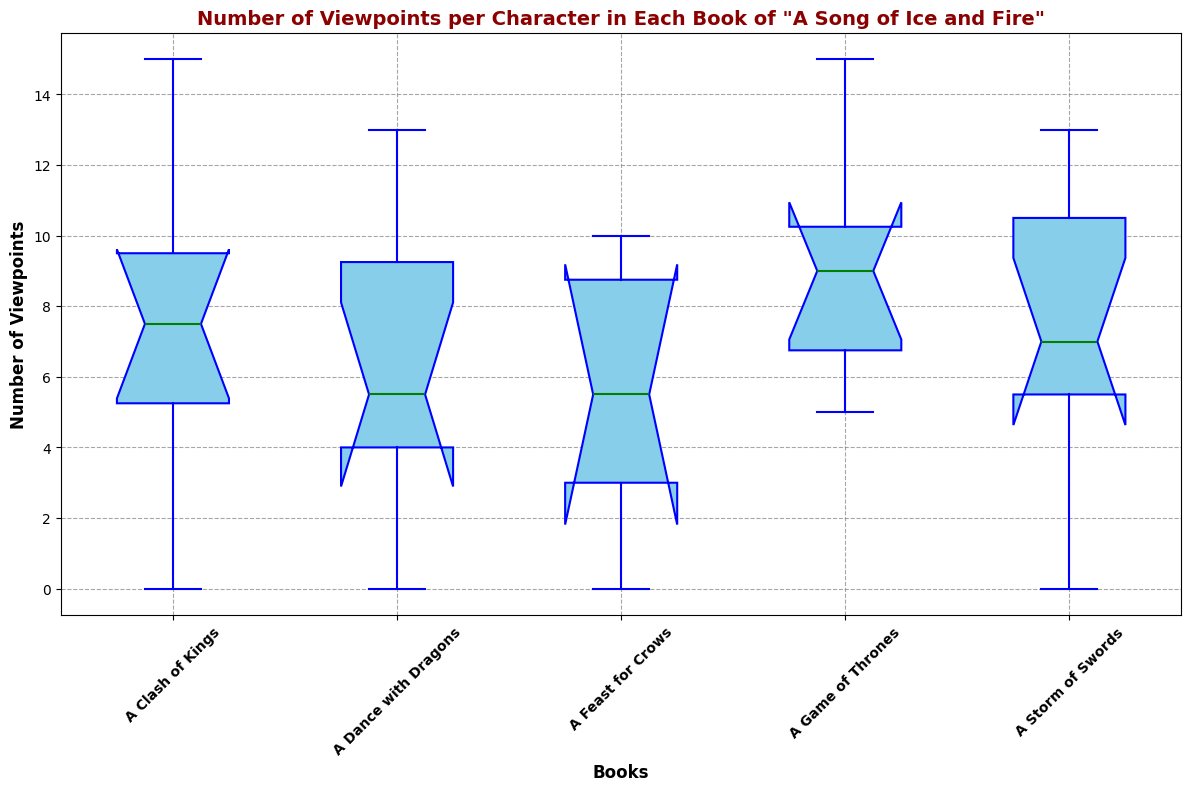How many viewpoints does the character with the highest median number of viewpoints have in the series? To identify this, we need to examine the median lines within each box plot. The character with the highest median would have the box plot with the highest line in the middle across all books. By looking at the median lines, we can determine the exact count for that character.
Answer: 10 viewpoints In which book is the median number of viewpoints the highest? Look at the median lines (green lines) within each box plot to determine the book with the highest median number of viewpoints. Find the book where this line is the highest above the x-axis.
Answer: A Storm of Swords Which book has the greatest range of viewpoints? The range is determined by the distance between the top whisker and the bottom whisker in the box plot. Locate the book with the longest spread between these whiskers indicating the greatest range.
Answer: A Game of Thrones How does the median number of viewpoints in A Clash of Kings compare to A Dance with Dragons? Compare the positions of the median lines (green lines) in both box plots for the two books. Check if the median line for A Clash of Kings is higher, lower, or at the same level as that of A Dance with Dragons.
Answer: A Clash of Kings has a lower median than A Dance with Dragons Which book has the most outliers, and how many are there? Identify the outliers as the red markers outside the whiskers of each box plot. Count the number of such red markers for each book and determine which has the most.
Answer: A Storm of Swords has the most outliers (3) In which book does the interquartile range (IQR) appear the narrowest? The IQR is shown by the height of the box itself (distance between the top and bottom of the box). Identify the box with the shortest height among the books.
Answer: A Dance with Dragons Is there any book where the minimum number of viewpoints is zero? Look at the bottom whisker of each box plot. If any whisker touches the x-axis, that book has a minimum of zero viewpoints.
Answer: Yes, A Storm of Swords and A Feast for Crows Are there any books where the median number of viewpoints is greater than the third quartile of any other book? If so, which one? Compare the median lines of each book with the top of the boxes of other books. Determine if any median line lies above the top of another book’s box.
Answer: Yes, A Dance with Dragons median is higher than the third quartile of A Clash of Kings Which book has the closest median and upper quartile (Q3) values? Examine the position of the median lines and the top edges of the boxes within each plot. The book with the smallest distance between its median line and top edge of its box has the closest values.
Answer: A Storm of Swords 